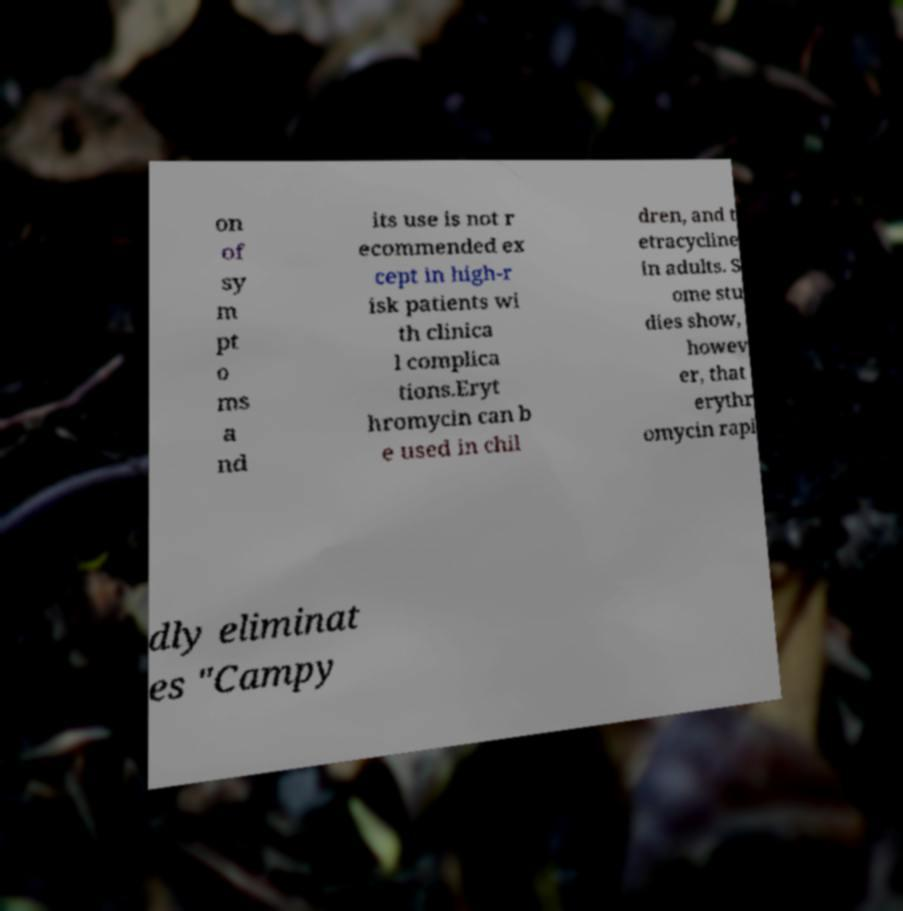There's text embedded in this image that I need extracted. Can you transcribe it verbatim? on of sy m pt o ms a nd its use is not r ecommended ex cept in high-r isk patients wi th clinica l complica tions.Eryt hromycin can b e used in chil dren, and t etracycline in adults. S ome stu dies show, howev er, that erythr omycin rapi dly eliminat es "Campy 